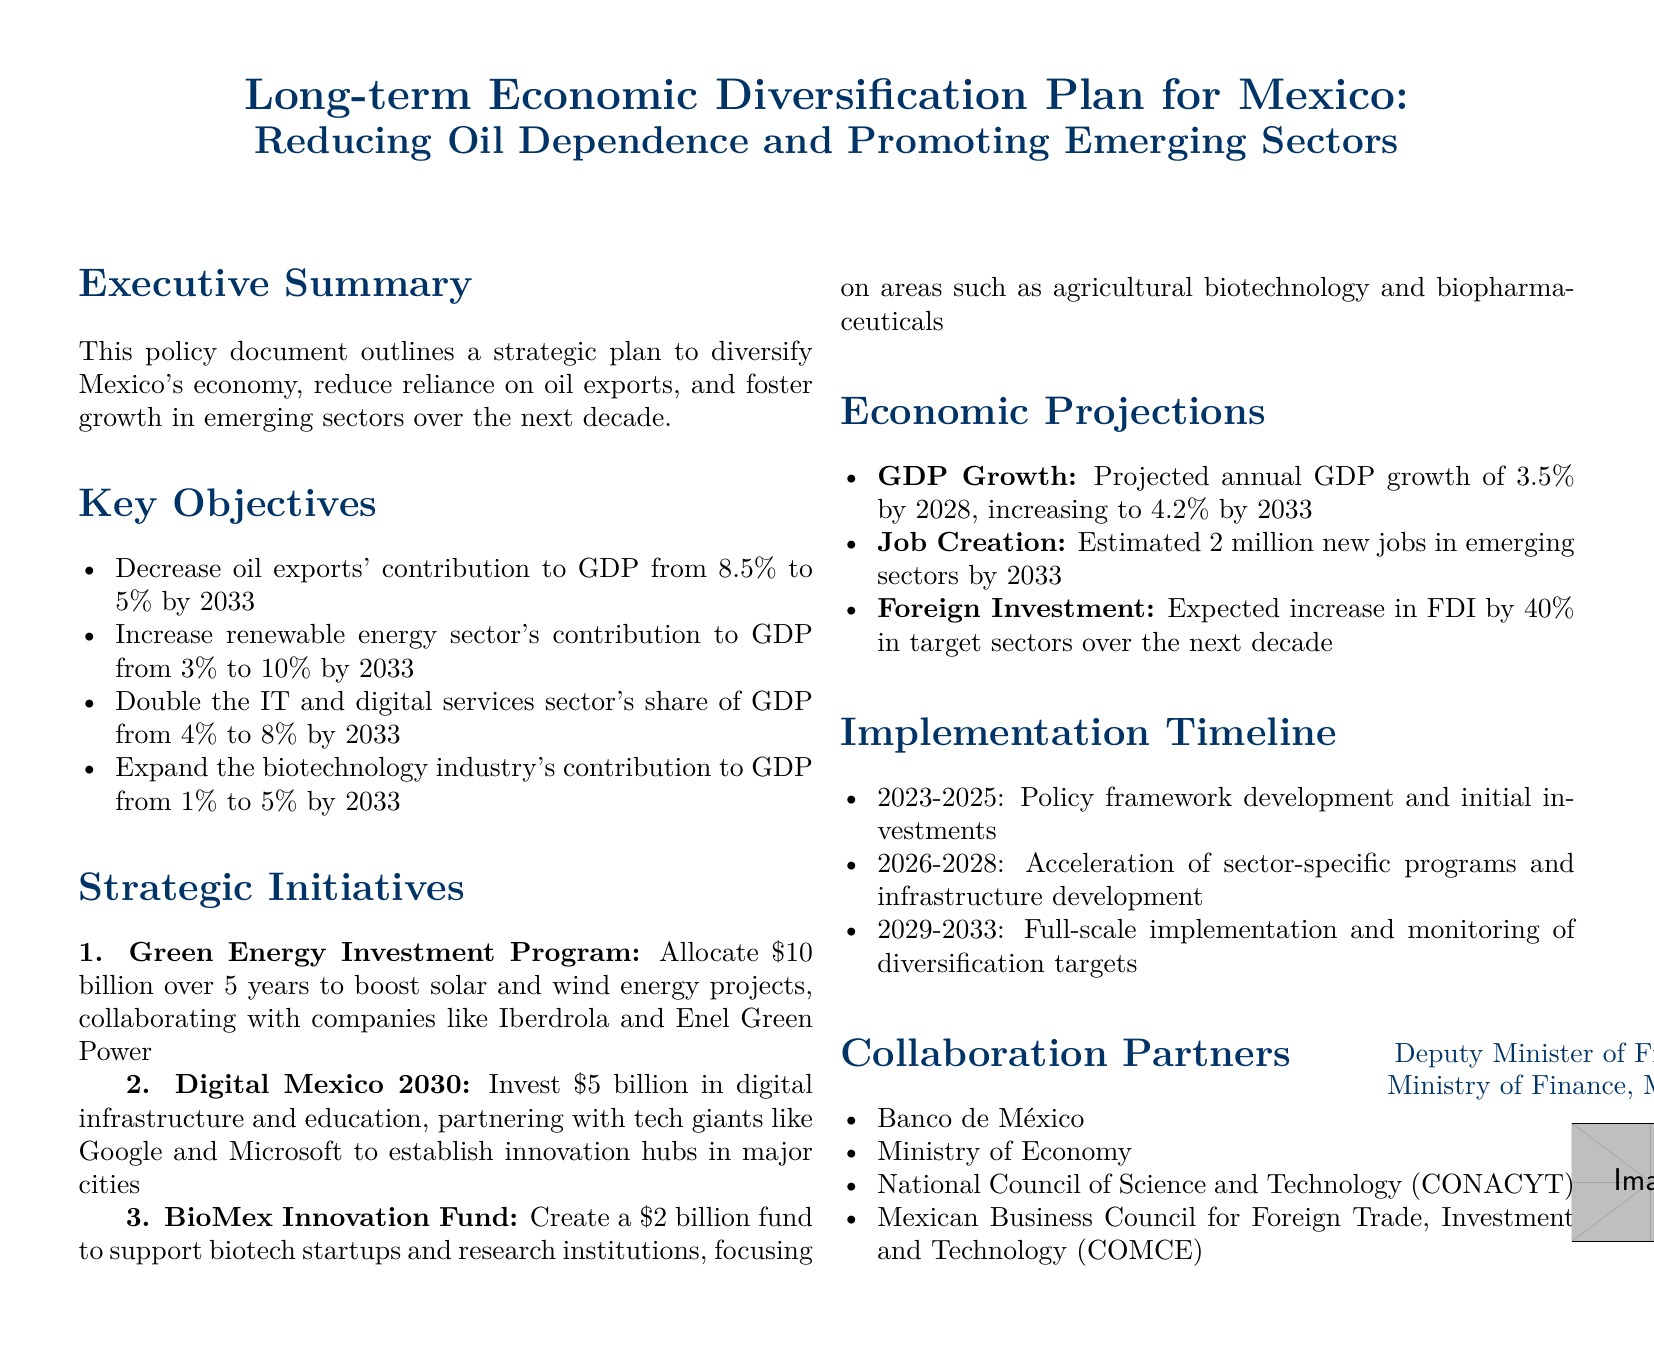What is the current contribution of oil exports to GDP? The document states that the current contribution of oil exports to GDP is 8.5%.
Answer: 8.5% What is the target contribution of renewable energy to GDP by 2033? The document specifies that the target for the renewable energy sector's contribution to GDP is 10% by 2033.
Answer: 10% How much investment is allocated for the Green Energy Investment Program? The document indicates that \$10 billion is allocated for the Green Energy Investment Program.
Answer: \$10 billion What is the projected annual GDP growth by 2028? The document projects an annual GDP growth of 3.5% by 2028.
Answer: 3.5% How many new jobs are estimated to be created in emerging sectors by 2033? The document estimates that 2 million new jobs will be created in emerging sectors by 2033.
Answer: 2 million What year does the full-scale implementation and monitoring phase begin? According to the document, the full-scale implementation and monitoring phase begins in 2029.
Answer: 2029 Which sector's GDP contribution is planned to double by 2033? The document states that the IT and digital services sector's share of GDP is planned to double by 2033.
Answer: IT and digital services sector What is the total amount allocated for the BioMex Innovation Fund? The document mentions that \$2 billion is allocated for the BioMex Innovation Fund.
Answer: \$2 billion Who are one of the collaboration partners listed in the document? The document lists Banco de México as one of the collaboration partners.
Answer: Banco de México 